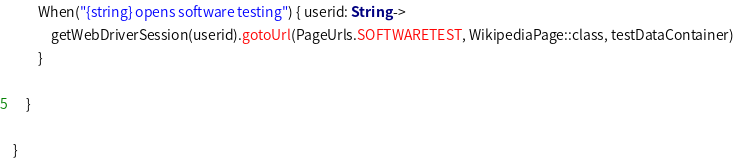Convert code to text. <code><loc_0><loc_0><loc_500><loc_500><_Kotlin_>        When("{string} opens software testing") { userid: String ->
            getWebDriverSession(userid).gotoUrl(PageUrls.SOFTWARETEST, WikipediaPage::class, testDataContainer)
        }

    }

}
</code> 